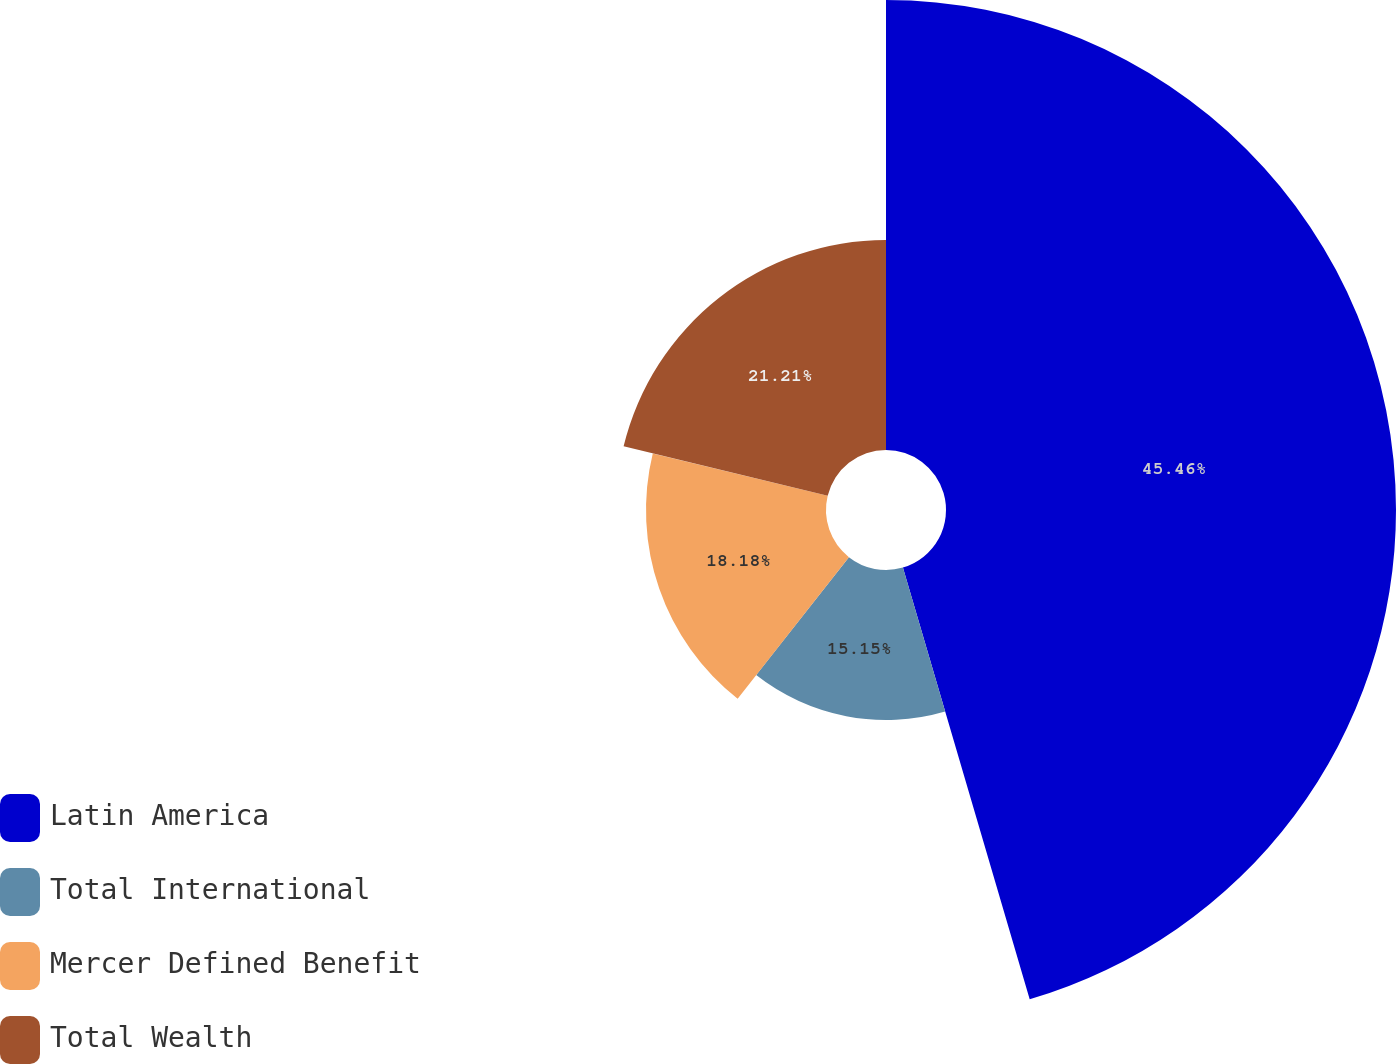Convert chart to OTSL. <chart><loc_0><loc_0><loc_500><loc_500><pie_chart><fcel>Latin America<fcel>Total International<fcel>Mercer Defined Benefit<fcel>Total Wealth<nl><fcel>45.45%<fcel>15.15%<fcel>18.18%<fcel>21.21%<nl></chart> 